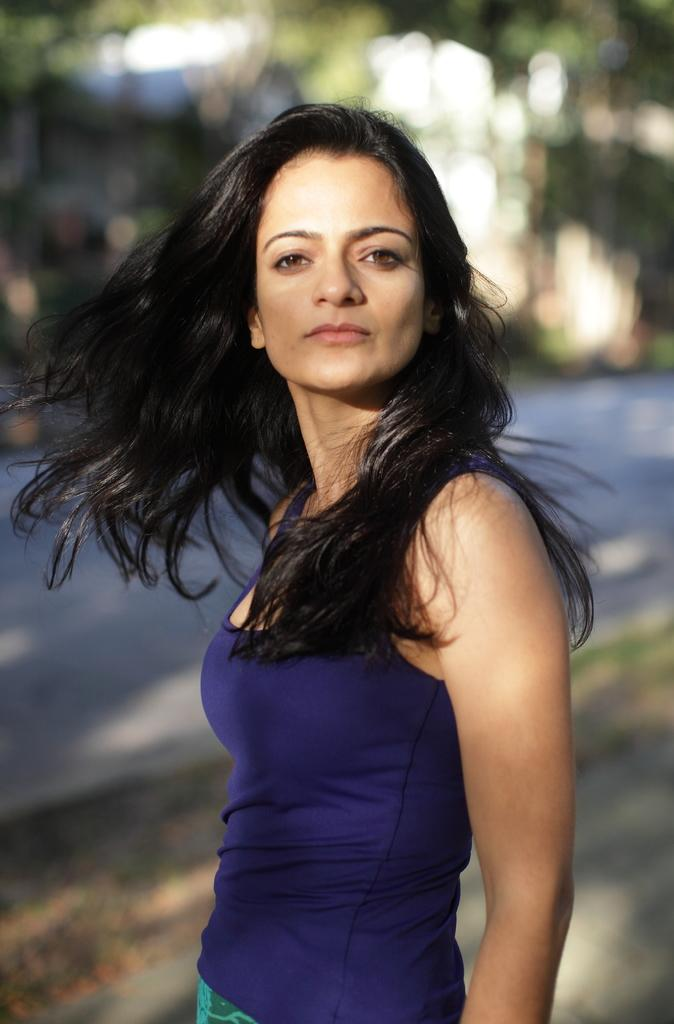What is the woman in the image wearing? The woman is wearing a blue shirt. Can you describe the backdrop of the image? There is a road and trees visible in the image, and the backdrop is blurred. What type of jeans is the woman wearing in the image? The provided facts do not mention the woman wearing jeans, only a blue shirt. How many attempts did the woman make to throw a quarter in the image? There is no quarter or any indication of an attempt to throw one in the image. 